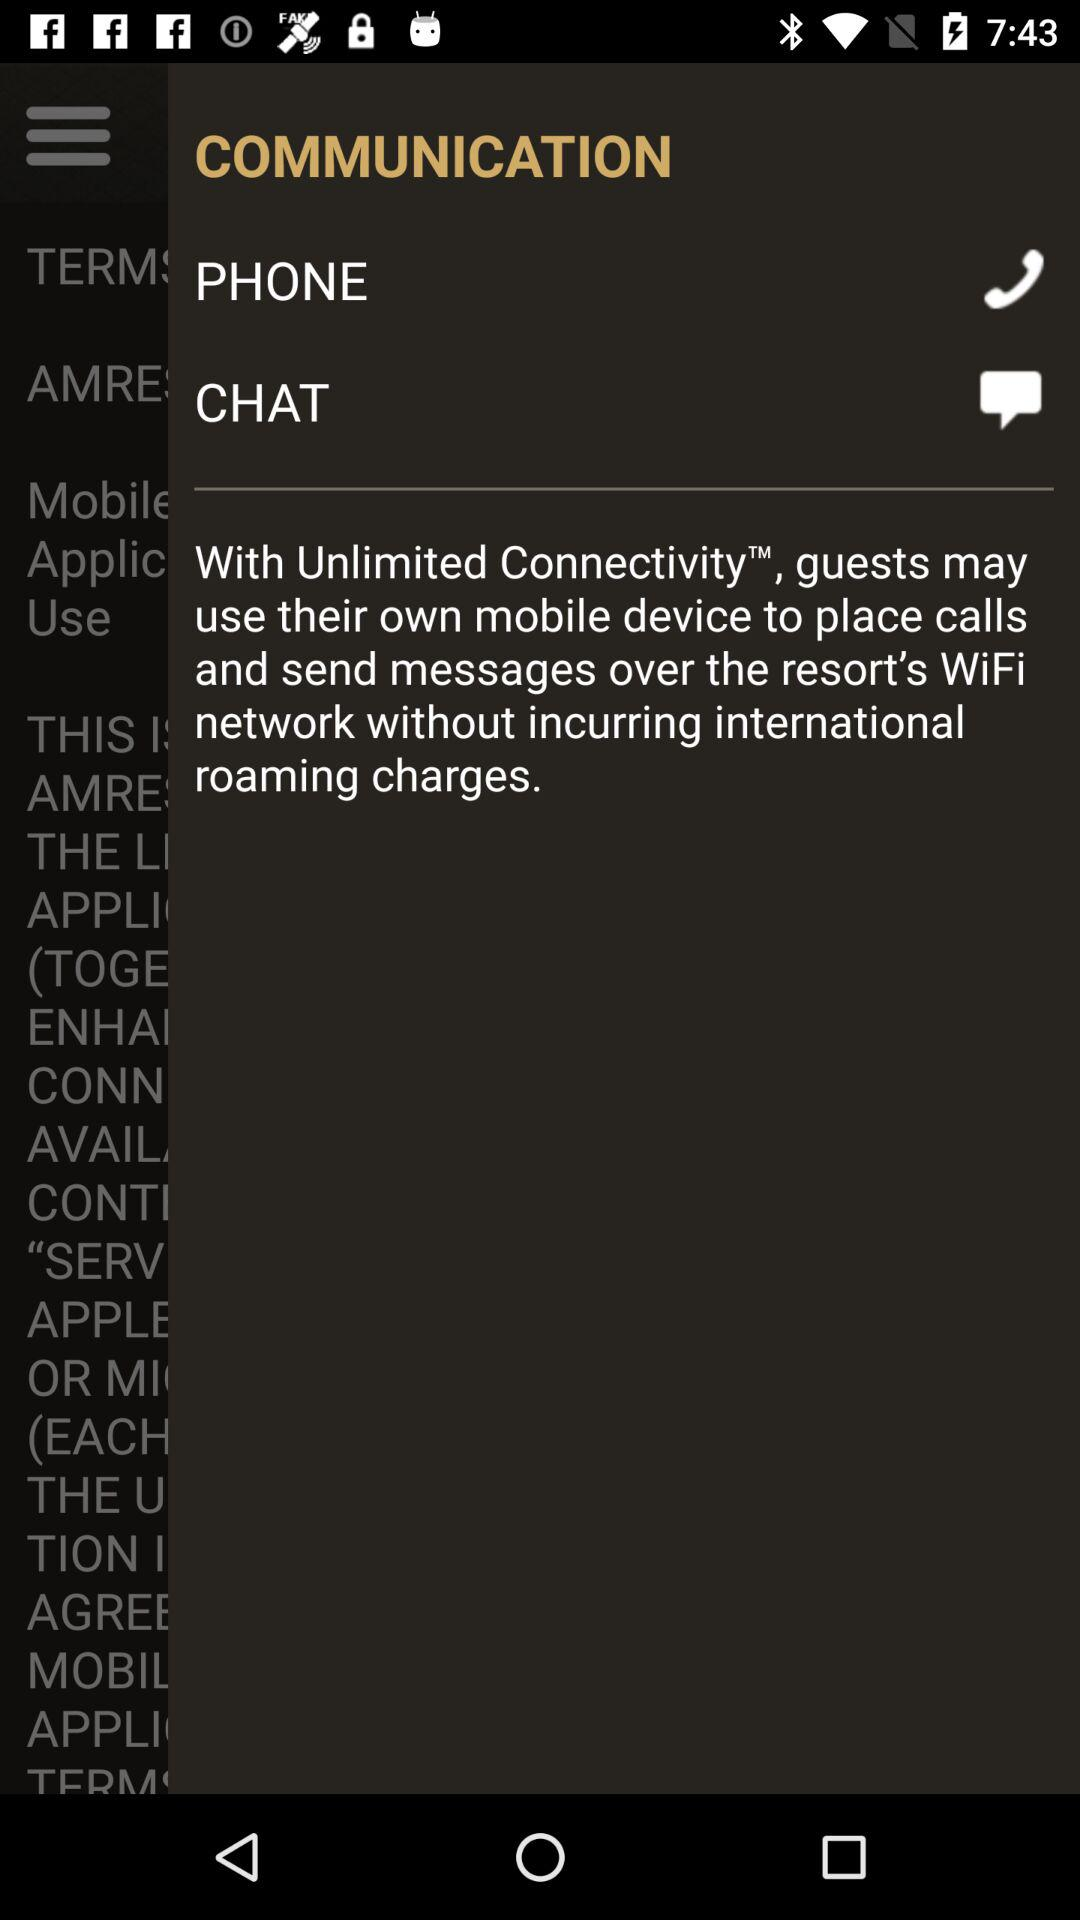Which resort does "Unlimited Connectivity" belong to?
When the provided information is insufficient, respond with <no answer>. <no answer> 